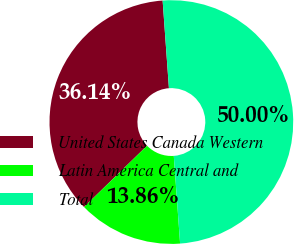Convert chart. <chart><loc_0><loc_0><loc_500><loc_500><pie_chart><fcel>United States Canada Western<fcel>Latin America Central and<fcel>Total<nl><fcel>36.14%<fcel>13.86%<fcel>50.0%<nl></chart> 